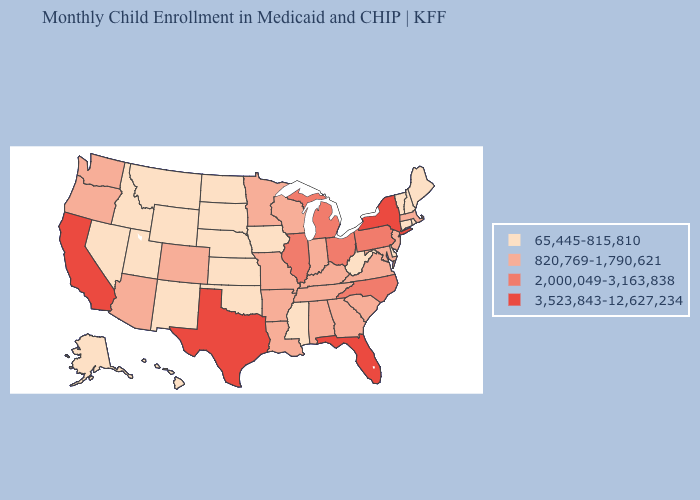Which states have the lowest value in the South?
Concise answer only. Delaware, Mississippi, Oklahoma, West Virginia. What is the lowest value in the MidWest?
Answer briefly. 65,445-815,810. What is the value of Georgia?
Quick response, please. 820,769-1,790,621. Which states have the lowest value in the Northeast?
Concise answer only. Connecticut, Maine, New Hampshire, Rhode Island, Vermont. What is the highest value in the Northeast ?
Answer briefly. 3,523,843-12,627,234. What is the lowest value in the South?
Keep it brief. 65,445-815,810. What is the lowest value in the West?
Quick response, please. 65,445-815,810. What is the value of Arkansas?
Answer briefly. 820,769-1,790,621. What is the lowest value in the USA?
Answer briefly. 65,445-815,810. What is the value of North Carolina?
Short answer required. 2,000,049-3,163,838. Does Oregon have a higher value than New York?
Write a very short answer. No. What is the highest value in the USA?
Quick response, please. 3,523,843-12,627,234. What is the lowest value in the USA?
Concise answer only. 65,445-815,810. Which states hav the highest value in the MidWest?
Quick response, please. Illinois, Michigan, Ohio. Name the states that have a value in the range 2,000,049-3,163,838?
Answer briefly. Illinois, Michigan, North Carolina, Ohio, Pennsylvania. 